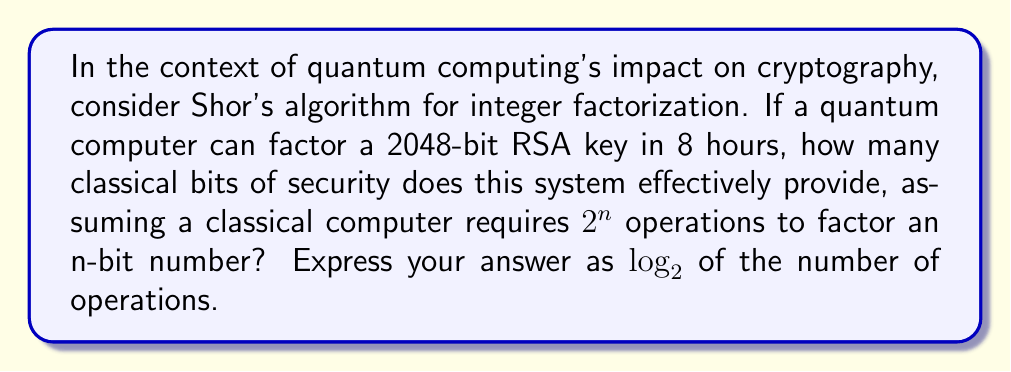Can you solve this math problem? Let's approach this step-by-step:

1) First, we need to understand the relationship between classical and quantum computing power for this problem:
   - Classical computers require approximately $2^n$ operations to factor an n-bit number.
   - Quantum computers, using Shor's algorithm, can factor in polynomial time, roughly $O(n^3)$.

2) We're told that a quantum computer can factor a 2048-bit RSA key in 8 hours.

3) To find the equivalent classical security, we need to determine how many bits a classical system would need to provide the same level of security (i.e., take the same time to break).

4) Let's say this equivalent classical system has $x$ bits. Then:
   
   $2^x \approx (2048)^3$

5) Taking $\log_2$ of both sides:

   $x \approx \log_2((2048)^3) = 3 \log_2(2048) = 3 * 11 = 33$

6) This means that the 2048-bit RSA system, when faced with a quantum computer, provides approximately the same security as a 33-bit classical system.

7) To express this in terms of the question, we need to calculate $\log_2$ of the number of operations:

   $\log_2(2^{33}) = 33$

Thus, the system effectively provides 33 bits of security against a quantum computer.
Answer: 33 